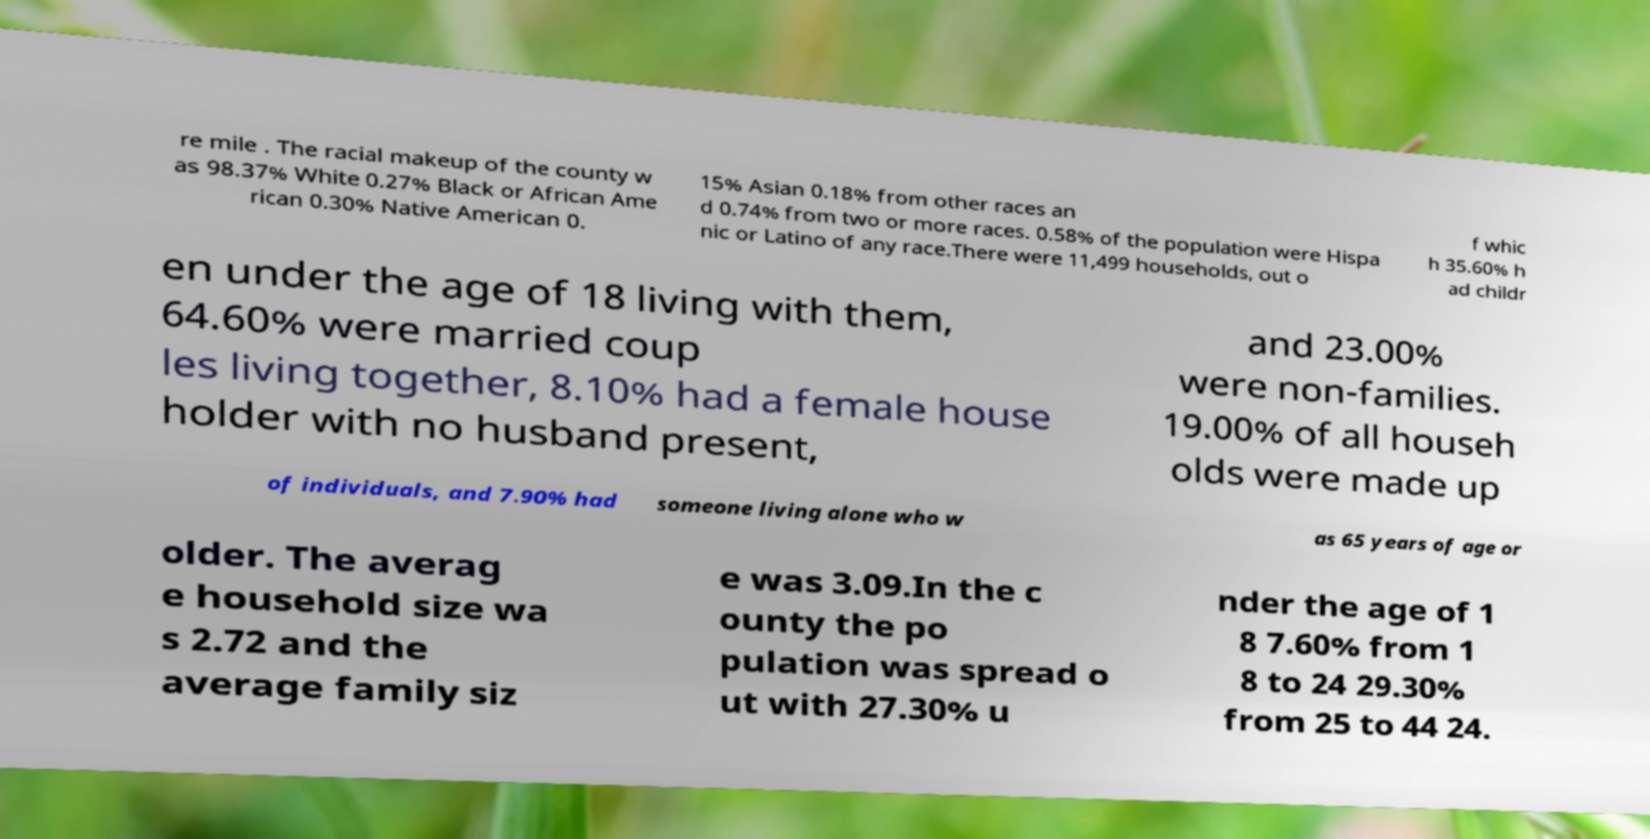Could you assist in decoding the text presented in this image and type it out clearly? re mile . The racial makeup of the county w as 98.37% White 0.27% Black or African Ame rican 0.30% Native American 0. 15% Asian 0.18% from other races an d 0.74% from two or more races. 0.58% of the population were Hispa nic or Latino of any race.There were 11,499 households, out o f whic h 35.60% h ad childr en under the age of 18 living with them, 64.60% were married coup les living together, 8.10% had a female house holder with no husband present, and 23.00% were non-families. 19.00% of all househ olds were made up of individuals, and 7.90% had someone living alone who w as 65 years of age or older. The averag e household size wa s 2.72 and the average family siz e was 3.09.In the c ounty the po pulation was spread o ut with 27.30% u nder the age of 1 8 7.60% from 1 8 to 24 29.30% from 25 to 44 24. 